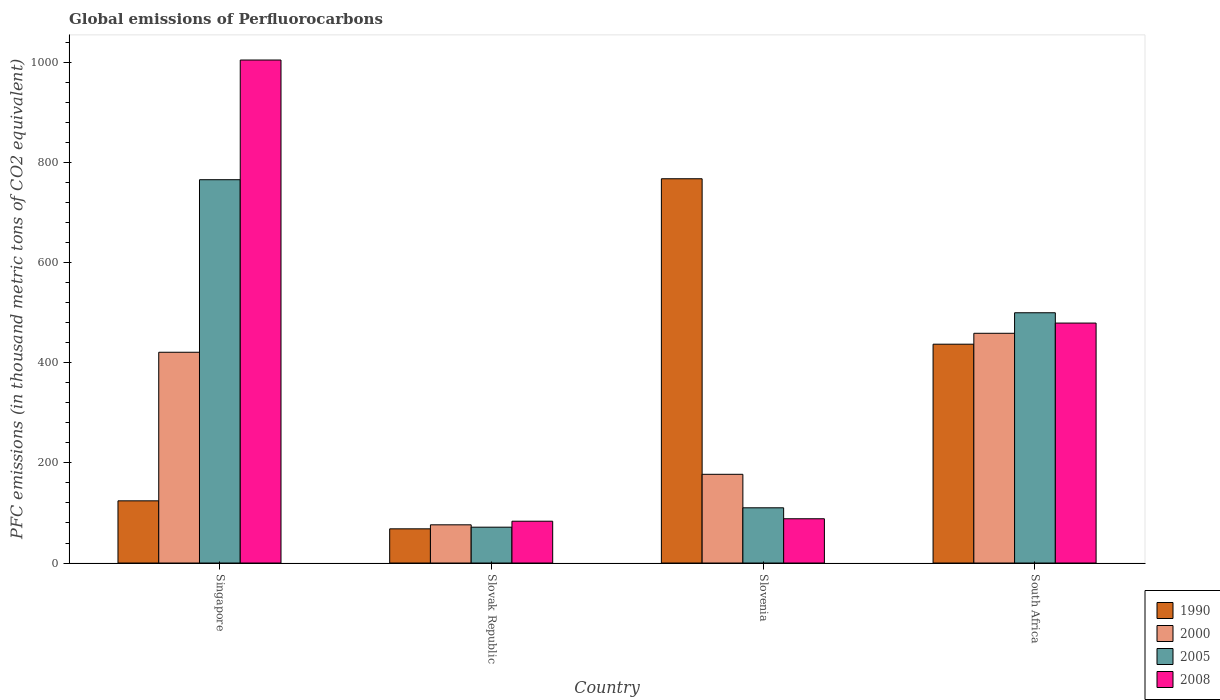Are the number of bars per tick equal to the number of legend labels?
Keep it short and to the point. Yes. Are the number of bars on each tick of the X-axis equal?
Give a very brief answer. Yes. How many bars are there on the 2nd tick from the left?
Your answer should be very brief. 4. How many bars are there on the 2nd tick from the right?
Make the answer very short. 4. What is the label of the 1st group of bars from the left?
Offer a terse response. Singapore. In how many cases, is the number of bars for a given country not equal to the number of legend labels?
Your response must be concise. 0. What is the global emissions of Perfluorocarbons in 2000 in Slovenia?
Provide a succinct answer. 177.2. Across all countries, what is the maximum global emissions of Perfluorocarbons in 2008?
Your answer should be compact. 1004.5. Across all countries, what is the minimum global emissions of Perfluorocarbons in 2005?
Your answer should be very brief. 71.6. In which country was the global emissions of Perfluorocarbons in 2008 maximum?
Your answer should be compact. Singapore. In which country was the global emissions of Perfluorocarbons in 1990 minimum?
Offer a very short reply. Slovak Republic. What is the total global emissions of Perfluorocarbons in 2000 in the graph?
Offer a terse response. 1133.2. What is the difference between the global emissions of Perfluorocarbons in 2008 in Slovenia and that in South Africa?
Provide a succinct answer. -390.8. What is the difference between the global emissions of Perfluorocarbons in 2000 in Slovenia and the global emissions of Perfluorocarbons in 1990 in Slovak Republic?
Your response must be concise. 108.9. What is the average global emissions of Perfluorocarbons in 2008 per country?
Ensure brevity in your answer.  413.9. What is the difference between the global emissions of Perfluorocarbons of/in 2008 and global emissions of Perfluorocarbons of/in 2000 in Slovak Republic?
Keep it short and to the point. 7.2. What is the ratio of the global emissions of Perfluorocarbons in 1990 in Slovenia to that in South Africa?
Give a very brief answer. 1.76. Is the global emissions of Perfluorocarbons in 2008 in Slovenia less than that in South Africa?
Provide a short and direct response. Yes. Is the difference between the global emissions of Perfluorocarbons in 2008 in Slovak Republic and South Africa greater than the difference between the global emissions of Perfluorocarbons in 2000 in Slovak Republic and South Africa?
Provide a short and direct response. No. What is the difference between the highest and the second highest global emissions of Perfluorocarbons in 2005?
Keep it short and to the point. -265.7. What is the difference between the highest and the lowest global emissions of Perfluorocarbons in 2008?
Offer a very short reply. 921. Is the sum of the global emissions of Perfluorocarbons in 1990 in Slovak Republic and Slovenia greater than the maximum global emissions of Perfluorocarbons in 2005 across all countries?
Offer a terse response. Yes. What does the 2nd bar from the right in Slovenia represents?
Ensure brevity in your answer.  2005. Is it the case that in every country, the sum of the global emissions of Perfluorocarbons in 1990 and global emissions of Perfluorocarbons in 2000 is greater than the global emissions of Perfluorocarbons in 2008?
Your answer should be compact. No. Are all the bars in the graph horizontal?
Keep it short and to the point. No. How many legend labels are there?
Offer a very short reply. 4. How are the legend labels stacked?
Your answer should be very brief. Vertical. What is the title of the graph?
Your answer should be compact. Global emissions of Perfluorocarbons. What is the label or title of the Y-axis?
Ensure brevity in your answer.  PFC emissions (in thousand metric tons of CO2 equivalent). What is the PFC emissions (in thousand metric tons of CO2 equivalent) of 1990 in Singapore?
Your answer should be very brief. 124.2. What is the PFC emissions (in thousand metric tons of CO2 equivalent) of 2000 in Singapore?
Your answer should be compact. 420.9. What is the PFC emissions (in thousand metric tons of CO2 equivalent) in 2005 in Singapore?
Your answer should be compact. 765.5. What is the PFC emissions (in thousand metric tons of CO2 equivalent) of 2008 in Singapore?
Offer a terse response. 1004.5. What is the PFC emissions (in thousand metric tons of CO2 equivalent) of 1990 in Slovak Republic?
Your answer should be very brief. 68.3. What is the PFC emissions (in thousand metric tons of CO2 equivalent) in 2000 in Slovak Republic?
Provide a short and direct response. 76.3. What is the PFC emissions (in thousand metric tons of CO2 equivalent) in 2005 in Slovak Republic?
Offer a terse response. 71.6. What is the PFC emissions (in thousand metric tons of CO2 equivalent) of 2008 in Slovak Republic?
Make the answer very short. 83.5. What is the PFC emissions (in thousand metric tons of CO2 equivalent) of 1990 in Slovenia?
Your answer should be compact. 767.4. What is the PFC emissions (in thousand metric tons of CO2 equivalent) of 2000 in Slovenia?
Provide a short and direct response. 177.2. What is the PFC emissions (in thousand metric tons of CO2 equivalent) in 2005 in Slovenia?
Your response must be concise. 110.3. What is the PFC emissions (in thousand metric tons of CO2 equivalent) in 2008 in Slovenia?
Give a very brief answer. 88.4. What is the PFC emissions (in thousand metric tons of CO2 equivalent) of 1990 in South Africa?
Ensure brevity in your answer.  437. What is the PFC emissions (in thousand metric tons of CO2 equivalent) in 2000 in South Africa?
Your answer should be very brief. 458.8. What is the PFC emissions (in thousand metric tons of CO2 equivalent) of 2005 in South Africa?
Your answer should be very brief. 499.8. What is the PFC emissions (in thousand metric tons of CO2 equivalent) of 2008 in South Africa?
Your answer should be compact. 479.2. Across all countries, what is the maximum PFC emissions (in thousand metric tons of CO2 equivalent) in 1990?
Ensure brevity in your answer.  767.4. Across all countries, what is the maximum PFC emissions (in thousand metric tons of CO2 equivalent) of 2000?
Your response must be concise. 458.8. Across all countries, what is the maximum PFC emissions (in thousand metric tons of CO2 equivalent) in 2005?
Offer a terse response. 765.5. Across all countries, what is the maximum PFC emissions (in thousand metric tons of CO2 equivalent) in 2008?
Keep it short and to the point. 1004.5. Across all countries, what is the minimum PFC emissions (in thousand metric tons of CO2 equivalent) in 1990?
Give a very brief answer. 68.3. Across all countries, what is the minimum PFC emissions (in thousand metric tons of CO2 equivalent) in 2000?
Provide a short and direct response. 76.3. Across all countries, what is the minimum PFC emissions (in thousand metric tons of CO2 equivalent) of 2005?
Your response must be concise. 71.6. Across all countries, what is the minimum PFC emissions (in thousand metric tons of CO2 equivalent) of 2008?
Provide a succinct answer. 83.5. What is the total PFC emissions (in thousand metric tons of CO2 equivalent) of 1990 in the graph?
Give a very brief answer. 1396.9. What is the total PFC emissions (in thousand metric tons of CO2 equivalent) in 2000 in the graph?
Make the answer very short. 1133.2. What is the total PFC emissions (in thousand metric tons of CO2 equivalent) of 2005 in the graph?
Give a very brief answer. 1447.2. What is the total PFC emissions (in thousand metric tons of CO2 equivalent) of 2008 in the graph?
Provide a short and direct response. 1655.6. What is the difference between the PFC emissions (in thousand metric tons of CO2 equivalent) in 1990 in Singapore and that in Slovak Republic?
Offer a very short reply. 55.9. What is the difference between the PFC emissions (in thousand metric tons of CO2 equivalent) of 2000 in Singapore and that in Slovak Republic?
Your response must be concise. 344.6. What is the difference between the PFC emissions (in thousand metric tons of CO2 equivalent) in 2005 in Singapore and that in Slovak Republic?
Provide a succinct answer. 693.9. What is the difference between the PFC emissions (in thousand metric tons of CO2 equivalent) of 2008 in Singapore and that in Slovak Republic?
Ensure brevity in your answer.  921. What is the difference between the PFC emissions (in thousand metric tons of CO2 equivalent) of 1990 in Singapore and that in Slovenia?
Provide a short and direct response. -643.2. What is the difference between the PFC emissions (in thousand metric tons of CO2 equivalent) of 2000 in Singapore and that in Slovenia?
Keep it short and to the point. 243.7. What is the difference between the PFC emissions (in thousand metric tons of CO2 equivalent) in 2005 in Singapore and that in Slovenia?
Make the answer very short. 655.2. What is the difference between the PFC emissions (in thousand metric tons of CO2 equivalent) in 2008 in Singapore and that in Slovenia?
Provide a short and direct response. 916.1. What is the difference between the PFC emissions (in thousand metric tons of CO2 equivalent) of 1990 in Singapore and that in South Africa?
Offer a very short reply. -312.8. What is the difference between the PFC emissions (in thousand metric tons of CO2 equivalent) in 2000 in Singapore and that in South Africa?
Give a very brief answer. -37.9. What is the difference between the PFC emissions (in thousand metric tons of CO2 equivalent) of 2005 in Singapore and that in South Africa?
Provide a succinct answer. 265.7. What is the difference between the PFC emissions (in thousand metric tons of CO2 equivalent) of 2008 in Singapore and that in South Africa?
Make the answer very short. 525.3. What is the difference between the PFC emissions (in thousand metric tons of CO2 equivalent) of 1990 in Slovak Republic and that in Slovenia?
Your answer should be very brief. -699.1. What is the difference between the PFC emissions (in thousand metric tons of CO2 equivalent) of 2000 in Slovak Republic and that in Slovenia?
Your response must be concise. -100.9. What is the difference between the PFC emissions (in thousand metric tons of CO2 equivalent) of 2005 in Slovak Republic and that in Slovenia?
Offer a terse response. -38.7. What is the difference between the PFC emissions (in thousand metric tons of CO2 equivalent) of 2008 in Slovak Republic and that in Slovenia?
Offer a terse response. -4.9. What is the difference between the PFC emissions (in thousand metric tons of CO2 equivalent) of 1990 in Slovak Republic and that in South Africa?
Your response must be concise. -368.7. What is the difference between the PFC emissions (in thousand metric tons of CO2 equivalent) of 2000 in Slovak Republic and that in South Africa?
Offer a very short reply. -382.5. What is the difference between the PFC emissions (in thousand metric tons of CO2 equivalent) of 2005 in Slovak Republic and that in South Africa?
Make the answer very short. -428.2. What is the difference between the PFC emissions (in thousand metric tons of CO2 equivalent) of 2008 in Slovak Republic and that in South Africa?
Your response must be concise. -395.7. What is the difference between the PFC emissions (in thousand metric tons of CO2 equivalent) in 1990 in Slovenia and that in South Africa?
Make the answer very short. 330.4. What is the difference between the PFC emissions (in thousand metric tons of CO2 equivalent) of 2000 in Slovenia and that in South Africa?
Your response must be concise. -281.6. What is the difference between the PFC emissions (in thousand metric tons of CO2 equivalent) in 2005 in Slovenia and that in South Africa?
Give a very brief answer. -389.5. What is the difference between the PFC emissions (in thousand metric tons of CO2 equivalent) of 2008 in Slovenia and that in South Africa?
Offer a terse response. -390.8. What is the difference between the PFC emissions (in thousand metric tons of CO2 equivalent) of 1990 in Singapore and the PFC emissions (in thousand metric tons of CO2 equivalent) of 2000 in Slovak Republic?
Your response must be concise. 47.9. What is the difference between the PFC emissions (in thousand metric tons of CO2 equivalent) in 1990 in Singapore and the PFC emissions (in thousand metric tons of CO2 equivalent) in 2005 in Slovak Republic?
Make the answer very short. 52.6. What is the difference between the PFC emissions (in thousand metric tons of CO2 equivalent) of 1990 in Singapore and the PFC emissions (in thousand metric tons of CO2 equivalent) of 2008 in Slovak Republic?
Make the answer very short. 40.7. What is the difference between the PFC emissions (in thousand metric tons of CO2 equivalent) in 2000 in Singapore and the PFC emissions (in thousand metric tons of CO2 equivalent) in 2005 in Slovak Republic?
Give a very brief answer. 349.3. What is the difference between the PFC emissions (in thousand metric tons of CO2 equivalent) of 2000 in Singapore and the PFC emissions (in thousand metric tons of CO2 equivalent) of 2008 in Slovak Republic?
Provide a succinct answer. 337.4. What is the difference between the PFC emissions (in thousand metric tons of CO2 equivalent) of 2005 in Singapore and the PFC emissions (in thousand metric tons of CO2 equivalent) of 2008 in Slovak Republic?
Offer a terse response. 682. What is the difference between the PFC emissions (in thousand metric tons of CO2 equivalent) of 1990 in Singapore and the PFC emissions (in thousand metric tons of CO2 equivalent) of 2000 in Slovenia?
Your response must be concise. -53. What is the difference between the PFC emissions (in thousand metric tons of CO2 equivalent) of 1990 in Singapore and the PFC emissions (in thousand metric tons of CO2 equivalent) of 2005 in Slovenia?
Your answer should be very brief. 13.9. What is the difference between the PFC emissions (in thousand metric tons of CO2 equivalent) of 1990 in Singapore and the PFC emissions (in thousand metric tons of CO2 equivalent) of 2008 in Slovenia?
Offer a terse response. 35.8. What is the difference between the PFC emissions (in thousand metric tons of CO2 equivalent) in 2000 in Singapore and the PFC emissions (in thousand metric tons of CO2 equivalent) in 2005 in Slovenia?
Your answer should be compact. 310.6. What is the difference between the PFC emissions (in thousand metric tons of CO2 equivalent) in 2000 in Singapore and the PFC emissions (in thousand metric tons of CO2 equivalent) in 2008 in Slovenia?
Provide a succinct answer. 332.5. What is the difference between the PFC emissions (in thousand metric tons of CO2 equivalent) of 2005 in Singapore and the PFC emissions (in thousand metric tons of CO2 equivalent) of 2008 in Slovenia?
Your answer should be compact. 677.1. What is the difference between the PFC emissions (in thousand metric tons of CO2 equivalent) of 1990 in Singapore and the PFC emissions (in thousand metric tons of CO2 equivalent) of 2000 in South Africa?
Offer a very short reply. -334.6. What is the difference between the PFC emissions (in thousand metric tons of CO2 equivalent) in 1990 in Singapore and the PFC emissions (in thousand metric tons of CO2 equivalent) in 2005 in South Africa?
Your answer should be compact. -375.6. What is the difference between the PFC emissions (in thousand metric tons of CO2 equivalent) of 1990 in Singapore and the PFC emissions (in thousand metric tons of CO2 equivalent) of 2008 in South Africa?
Ensure brevity in your answer.  -355. What is the difference between the PFC emissions (in thousand metric tons of CO2 equivalent) of 2000 in Singapore and the PFC emissions (in thousand metric tons of CO2 equivalent) of 2005 in South Africa?
Give a very brief answer. -78.9. What is the difference between the PFC emissions (in thousand metric tons of CO2 equivalent) in 2000 in Singapore and the PFC emissions (in thousand metric tons of CO2 equivalent) in 2008 in South Africa?
Ensure brevity in your answer.  -58.3. What is the difference between the PFC emissions (in thousand metric tons of CO2 equivalent) in 2005 in Singapore and the PFC emissions (in thousand metric tons of CO2 equivalent) in 2008 in South Africa?
Provide a short and direct response. 286.3. What is the difference between the PFC emissions (in thousand metric tons of CO2 equivalent) of 1990 in Slovak Republic and the PFC emissions (in thousand metric tons of CO2 equivalent) of 2000 in Slovenia?
Provide a succinct answer. -108.9. What is the difference between the PFC emissions (in thousand metric tons of CO2 equivalent) in 1990 in Slovak Republic and the PFC emissions (in thousand metric tons of CO2 equivalent) in 2005 in Slovenia?
Your answer should be very brief. -42. What is the difference between the PFC emissions (in thousand metric tons of CO2 equivalent) in 1990 in Slovak Republic and the PFC emissions (in thousand metric tons of CO2 equivalent) in 2008 in Slovenia?
Ensure brevity in your answer.  -20.1. What is the difference between the PFC emissions (in thousand metric tons of CO2 equivalent) in 2000 in Slovak Republic and the PFC emissions (in thousand metric tons of CO2 equivalent) in 2005 in Slovenia?
Ensure brevity in your answer.  -34. What is the difference between the PFC emissions (in thousand metric tons of CO2 equivalent) in 2005 in Slovak Republic and the PFC emissions (in thousand metric tons of CO2 equivalent) in 2008 in Slovenia?
Ensure brevity in your answer.  -16.8. What is the difference between the PFC emissions (in thousand metric tons of CO2 equivalent) in 1990 in Slovak Republic and the PFC emissions (in thousand metric tons of CO2 equivalent) in 2000 in South Africa?
Keep it short and to the point. -390.5. What is the difference between the PFC emissions (in thousand metric tons of CO2 equivalent) in 1990 in Slovak Republic and the PFC emissions (in thousand metric tons of CO2 equivalent) in 2005 in South Africa?
Your response must be concise. -431.5. What is the difference between the PFC emissions (in thousand metric tons of CO2 equivalent) of 1990 in Slovak Republic and the PFC emissions (in thousand metric tons of CO2 equivalent) of 2008 in South Africa?
Give a very brief answer. -410.9. What is the difference between the PFC emissions (in thousand metric tons of CO2 equivalent) of 2000 in Slovak Republic and the PFC emissions (in thousand metric tons of CO2 equivalent) of 2005 in South Africa?
Your answer should be compact. -423.5. What is the difference between the PFC emissions (in thousand metric tons of CO2 equivalent) of 2000 in Slovak Republic and the PFC emissions (in thousand metric tons of CO2 equivalent) of 2008 in South Africa?
Give a very brief answer. -402.9. What is the difference between the PFC emissions (in thousand metric tons of CO2 equivalent) in 2005 in Slovak Republic and the PFC emissions (in thousand metric tons of CO2 equivalent) in 2008 in South Africa?
Your answer should be compact. -407.6. What is the difference between the PFC emissions (in thousand metric tons of CO2 equivalent) of 1990 in Slovenia and the PFC emissions (in thousand metric tons of CO2 equivalent) of 2000 in South Africa?
Ensure brevity in your answer.  308.6. What is the difference between the PFC emissions (in thousand metric tons of CO2 equivalent) in 1990 in Slovenia and the PFC emissions (in thousand metric tons of CO2 equivalent) in 2005 in South Africa?
Offer a terse response. 267.6. What is the difference between the PFC emissions (in thousand metric tons of CO2 equivalent) of 1990 in Slovenia and the PFC emissions (in thousand metric tons of CO2 equivalent) of 2008 in South Africa?
Give a very brief answer. 288.2. What is the difference between the PFC emissions (in thousand metric tons of CO2 equivalent) of 2000 in Slovenia and the PFC emissions (in thousand metric tons of CO2 equivalent) of 2005 in South Africa?
Ensure brevity in your answer.  -322.6. What is the difference between the PFC emissions (in thousand metric tons of CO2 equivalent) of 2000 in Slovenia and the PFC emissions (in thousand metric tons of CO2 equivalent) of 2008 in South Africa?
Your answer should be very brief. -302. What is the difference between the PFC emissions (in thousand metric tons of CO2 equivalent) in 2005 in Slovenia and the PFC emissions (in thousand metric tons of CO2 equivalent) in 2008 in South Africa?
Offer a terse response. -368.9. What is the average PFC emissions (in thousand metric tons of CO2 equivalent) in 1990 per country?
Provide a succinct answer. 349.23. What is the average PFC emissions (in thousand metric tons of CO2 equivalent) of 2000 per country?
Offer a very short reply. 283.3. What is the average PFC emissions (in thousand metric tons of CO2 equivalent) of 2005 per country?
Ensure brevity in your answer.  361.8. What is the average PFC emissions (in thousand metric tons of CO2 equivalent) of 2008 per country?
Offer a terse response. 413.9. What is the difference between the PFC emissions (in thousand metric tons of CO2 equivalent) of 1990 and PFC emissions (in thousand metric tons of CO2 equivalent) of 2000 in Singapore?
Offer a very short reply. -296.7. What is the difference between the PFC emissions (in thousand metric tons of CO2 equivalent) in 1990 and PFC emissions (in thousand metric tons of CO2 equivalent) in 2005 in Singapore?
Ensure brevity in your answer.  -641.3. What is the difference between the PFC emissions (in thousand metric tons of CO2 equivalent) of 1990 and PFC emissions (in thousand metric tons of CO2 equivalent) of 2008 in Singapore?
Offer a terse response. -880.3. What is the difference between the PFC emissions (in thousand metric tons of CO2 equivalent) in 2000 and PFC emissions (in thousand metric tons of CO2 equivalent) in 2005 in Singapore?
Offer a very short reply. -344.6. What is the difference between the PFC emissions (in thousand metric tons of CO2 equivalent) in 2000 and PFC emissions (in thousand metric tons of CO2 equivalent) in 2008 in Singapore?
Make the answer very short. -583.6. What is the difference between the PFC emissions (in thousand metric tons of CO2 equivalent) of 2005 and PFC emissions (in thousand metric tons of CO2 equivalent) of 2008 in Singapore?
Offer a very short reply. -239. What is the difference between the PFC emissions (in thousand metric tons of CO2 equivalent) in 1990 and PFC emissions (in thousand metric tons of CO2 equivalent) in 2000 in Slovak Republic?
Your response must be concise. -8. What is the difference between the PFC emissions (in thousand metric tons of CO2 equivalent) in 1990 and PFC emissions (in thousand metric tons of CO2 equivalent) in 2008 in Slovak Republic?
Provide a succinct answer. -15.2. What is the difference between the PFC emissions (in thousand metric tons of CO2 equivalent) of 2000 and PFC emissions (in thousand metric tons of CO2 equivalent) of 2005 in Slovak Republic?
Your answer should be compact. 4.7. What is the difference between the PFC emissions (in thousand metric tons of CO2 equivalent) of 1990 and PFC emissions (in thousand metric tons of CO2 equivalent) of 2000 in Slovenia?
Ensure brevity in your answer.  590.2. What is the difference between the PFC emissions (in thousand metric tons of CO2 equivalent) of 1990 and PFC emissions (in thousand metric tons of CO2 equivalent) of 2005 in Slovenia?
Keep it short and to the point. 657.1. What is the difference between the PFC emissions (in thousand metric tons of CO2 equivalent) of 1990 and PFC emissions (in thousand metric tons of CO2 equivalent) of 2008 in Slovenia?
Your answer should be very brief. 679. What is the difference between the PFC emissions (in thousand metric tons of CO2 equivalent) of 2000 and PFC emissions (in thousand metric tons of CO2 equivalent) of 2005 in Slovenia?
Make the answer very short. 66.9. What is the difference between the PFC emissions (in thousand metric tons of CO2 equivalent) in 2000 and PFC emissions (in thousand metric tons of CO2 equivalent) in 2008 in Slovenia?
Your response must be concise. 88.8. What is the difference between the PFC emissions (in thousand metric tons of CO2 equivalent) in 2005 and PFC emissions (in thousand metric tons of CO2 equivalent) in 2008 in Slovenia?
Give a very brief answer. 21.9. What is the difference between the PFC emissions (in thousand metric tons of CO2 equivalent) in 1990 and PFC emissions (in thousand metric tons of CO2 equivalent) in 2000 in South Africa?
Keep it short and to the point. -21.8. What is the difference between the PFC emissions (in thousand metric tons of CO2 equivalent) of 1990 and PFC emissions (in thousand metric tons of CO2 equivalent) of 2005 in South Africa?
Offer a very short reply. -62.8. What is the difference between the PFC emissions (in thousand metric tons of CO2 equivalent) in 1990 and PFC emissions (in thousand metric tons of CO2 equivalent) in 2008 in South Africa?
Ensure brevity in your answer.  -42.2. What is the difference between the PFC emissions (in thousand metric tons of CO2 equivalent) in 2000 and PFC emissions (in thousand metric tons of CO2 equivalent) in 2005 in South Africa?
Offer a very short reply. -41. What is the difference between the PFC emissions (in thousand metric tons of CO2 equivalent) in 2000 and PFC emissions (in thousand metric tons of CO2 equivalent) in 2008 in South Africa?
Make the answer very short. -20.4. What is the difference between the PFC emissions (in thousand metric tons of CO2 equivalent) in 2005 and PFC emissions (in thousand metric tons of CO2 equivalent) in 2008 in South Africa?
Ensure brevity in your answer.  20.6. What is the ratio of the PFC emissions (in thousand metric tons of CO2 equivalent) in 1990 in Singapore to that in Slovak Republic?
Your answer should be very brief. 1.82. What is the ratio of the PFC emissions (in thousand metric tons of CO2 equivalent) of 2000 in Singapore to that in Slovak Republic?
Ensure brevity in your answer.  5.52. What is the ratio of the PFC emissions (in thousand metric tons of CO2 equivalent) in 2005 in Singapore to that in Slovak Republic?
Your answer should be compact. 10.69. What is the ratio of the PFC emissions (in thousand metric tons of CO2 equivalent) of 2008 in Singapore to that in Slovak Republic?
Give a very brief answer. 12.03. What is the ratio of the PFC emissions (in thousand metric tons of CO2 equivalent) in 1990 in Singapore to that in Slovenia?
Offer a very short reply. 0.16. What is the ratio of the PFC emissions (in thousand metric tons of CO2 equivalent) in 2000 in Singapore to that in Slovenia?
Offer a terse response. 2.38. What is the ratio of the PFC emissions (in thousand metric tons of CO2 equivalent) of 2005 in Singapore to that in Slovenia?
Offer a terse response. 6.94. What is the ratio of the PFC emissions (in thousand metric tons of CO2 equivalent) in 2008 in Singapore to that in Slovenia?
Make the answer very short. 11.36. What is the ratio of the PFC emissions (in thousand metric tons of CO2 equivalent) of 1990 in Singapore to that in South Africa?
Provide a succinct answer. 0.28. What is the ratio of the PFC emissions (in thousand metric tons of CO2 equivalent) in 2000 in Singapore to that in South Africa?
Make the answer very short. 0.92. What is the ratio of the PFC emissions (in thousand metric tons of CO2 equivalent) of 2005 in Singapore to that in South Africa?
Provide a succinct answer. 1.53. What is the ratio of the PFC emissions (in thousand metric tons of CO2 equivalent) in 2008 in Singapore to that in South Africa?
Your response must be concise. 2.1. What is the ratio of the PFC emissions (in thousand metric tons of CO2 equivalent) in 1990 in Slovak Republic to that in Slovenia?
Provide a succinct answer. 0.09. What is the ratio of the PFC emissions (in thousand metric tons of CO2 equivalent) in 2000 in Slovak Republic to that in Slovenia?
Offer a very short reply. 0.43. What is the ratio of the PFC emissions (in thousand metric tons of CO2 equivalent) in 2005 in Slovak Republic to that in Slovenia?
Offer a terse response. 0.65. What is the ratio of the PFC emissions (in thousand metric tons of CO2 equivalent) of 2008 in Slovak Republic to that in Slovenia?
Give a very brief answer. 0.94. What is the ratio of the PFC emissions (in thousand metric tons of CO2 equivalent) of 1990 in Slovak Republic to that in South Africa?
Provide a succinct answer. 0.16. What is the ratio of the PFC emissions (in thousand metric tons of CO2 equivalent) in 2000 in Slovak Republic to that in South Africa?
Your answer should be very brief. 0.17. What is the ratio of the PFC emissions (in thousand metric tons of CO2 equivalent) of 2005 in Slovak Republic to that in South Africa?
Offer a very short reply. 0.14. What is the ratio of the PFC emissions (in thousand metric tons of CO2 equivalent) of 2008 in Slovak Republic to that in South Africa?
Make the answer very short. 0.17. What is the ratio of the PFC emissions (in thousand metric tons of CO2 equivalent) of 1990 in Slovenia to that in South Africa?
Give a very brief answer. 1.76. What is the ratio of the PFC emissions (in thousand metric tons of CO2 equivalent) of 2000 in Slovenia to that in South Africa?
Keep it short and to the point. 0.39. What is the ratio of the PFC emissions (in thousand metric tons of CO2 equivalent) of 2005 in Slovenia to that in South Africa?
Provide a succinct answer. 0.22. What is the ratio of the PFC emissions (in thousand metric tons of CO2 equivalent) of 2008 in Slovenia to that in South Africa?
Make the answer very short. 0.18. What is the difference between the highest and the second highest PFC emissions (in thousand metric tons of CO2 equivalent) of 1990?
Ensure brevity in your answer.  330.4. What is the difference between the highest and the second highest PFC emissions (in thousand metric tons of CO2 equivalent) in 2000?
Make the answer very short. 37.9. What is the difference between the highest and the second highest PFC emissions (in thousand metric tons of CO2 equivalent) of 2005?
Keep it short and to the point. 265.7. What is the difference between the highest and the second highest PFC emissions (in thousand metric tons of CO2 equivalent) of 2008?
Ensure brevity in your answer.  525.3. What is the difference between the highest and the lowest PFC emissions (in thousand metric tons of CO2 equivalent) of 1990?
Make the answer very short. 699.1. What is the difference between the highest and the lowest PFC emissions (in thousand metric tons of CO2 equivalent) of 2000?
Make the answer very short. 382.5. What is the difference between the highest and the lowest PFC emissions (in thousand metric tons of CO2 equivalent) of 2005?
Your answer should be compact. 693.9. What is the difference between the highest and the lowest PFC emissions (in thousand metric tons of CO2 equivalent) of 2008?
Give a very brief answer. 921. 